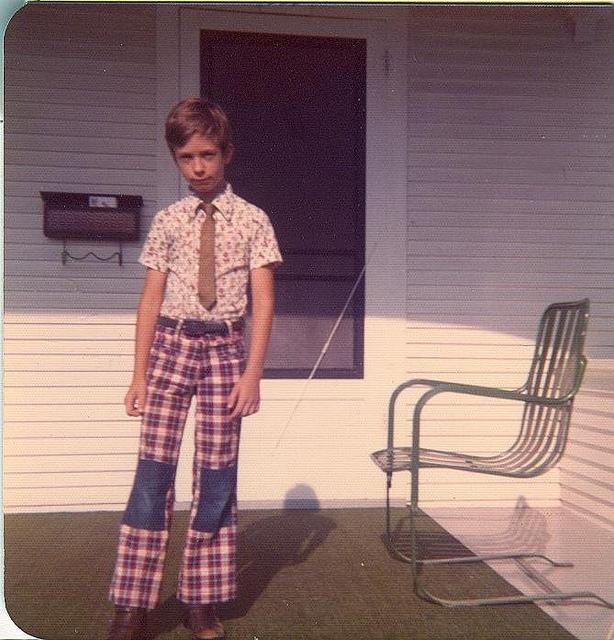Is he wearing a tie?
Write a very short answer. Yes. Are those pants still in style?
Quick response, please. No. What decade is this from?
Give a very brief answer. 70's. 